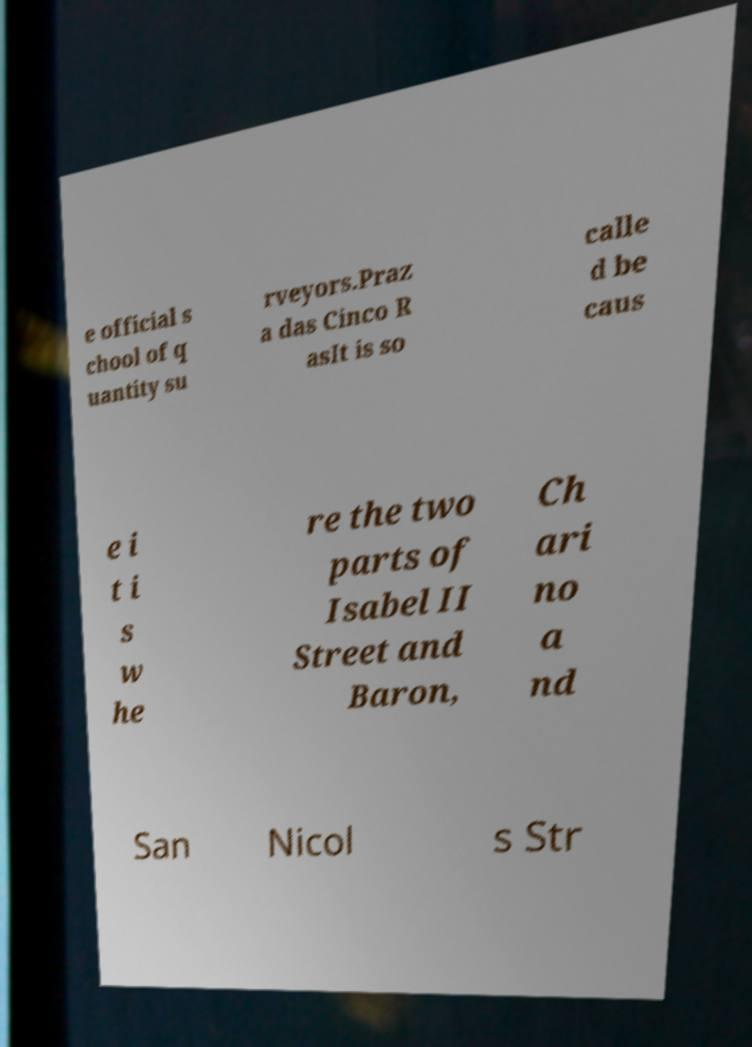There's text embedded in this image that I need extracted. Can you transcribe it verbatim? e official s chool of q uantity su rveyors.Praz a das Cinco R asIt is so calle d be caus e i t i s w he re the two parts of Isabel II Street and Baron, Ch ari no a nd San Nicol s Str 